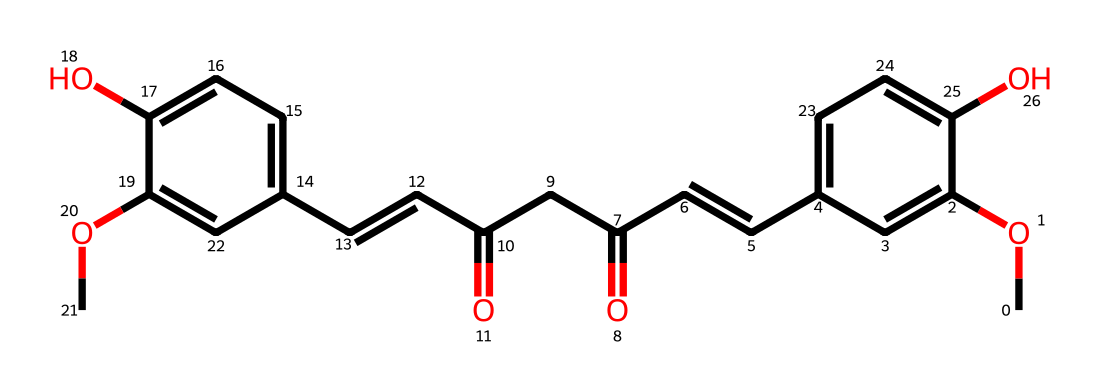What is the molecular formula of curcumin based on its SMILES? The SMILES representation can be translated to determine the number of each type of atom. By analyzing the structure, we can count the carbon (C), hydrogen (H), and oxygen (O) atoms present. This specific SMILES denotes that curcumin has 21 Carbon atoms, 20 Hydrogen atoms, and 6 Oxygen atoms, leading to the molecular formula C21H20O6.
Answer: C21H20O6 How many hydroxyl groups (-OH) are present in curcumin? In the provided SMILES, we can identify hydroxyl groups by looking for 'O' connected to a carbon without a double bond to another oxygen. Scanning through the structure shows that there are two instances of 'O' in this context, indicating two hydroxyl groups are present.
Answer: 2 What type of structural features indicate that curcumin is an antioxidant? Antioxidants often exhibit certain structural features such as phenolic groups and the ability to donate electrons. In curcumin's structure, the presence of hydroxyl groups is indicative of its antioxidant properties as they can easily donate hydrogen atoms, thus neutralizing free radicals.
Answer: hydroxyl groups Which part of the curcumin structure indicates unsaturation? In organic compounds, unsaturation typically occurs in the presence of double bonds. Within the provided SMILES, the '/C=C/' segments show double bonds, indicating unsaturation in the molecule.
Answer: C=C What is the total number of double bonds present in curcumin? To find the total number of double bonds in the structure, we look for the occurrences of '=' and '/' that indicate double bonds. By examining the SMILES format, we can count a total of four double bonds present in the structure.
Answer: 4 Which part of curcumin’s structure contributes to its yellow color? The yellow color in many natural compounds often arises from the presence of conjugated double bonds or certain chromophores. In curcumin, the extensive conjugation across its double bonds and the carbonyl groups contributes to the characteristic yellow color observed.
Answer: conjugated double bonds 